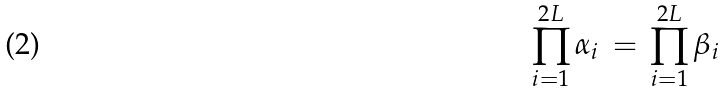<formula> <loc_0><loc_0><loc_500><loc_500>\prod _ { i = 1 } ^ { 2 L } \alpha _ { i } \, = \, \prod _ { i = 1 } ^ { 2 L } \beta _ { i }</formula> 